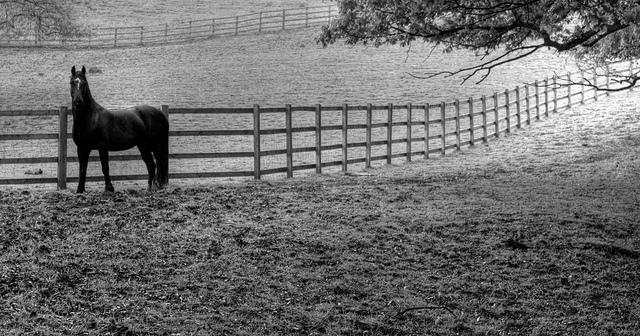What kind of animal is this?
Write a very short answer. Horse. What is the animal looking at?
Give a very brief answer. Camera. What animal is this?
Write a very short answer. Horse. How many horses are there?
Quick response, please. 1. Where is the horse?
Write a very short answer. By fence. 